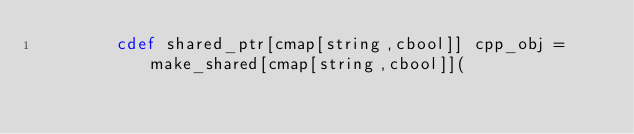Convert code to text. <code><loc_0><loc_0><loc_500><loc_500><_Cython_>        cdef shared_ptr[cmap[string,cbool]] cpp_obj = make_shared[cmap[string,cbool]](</code> 